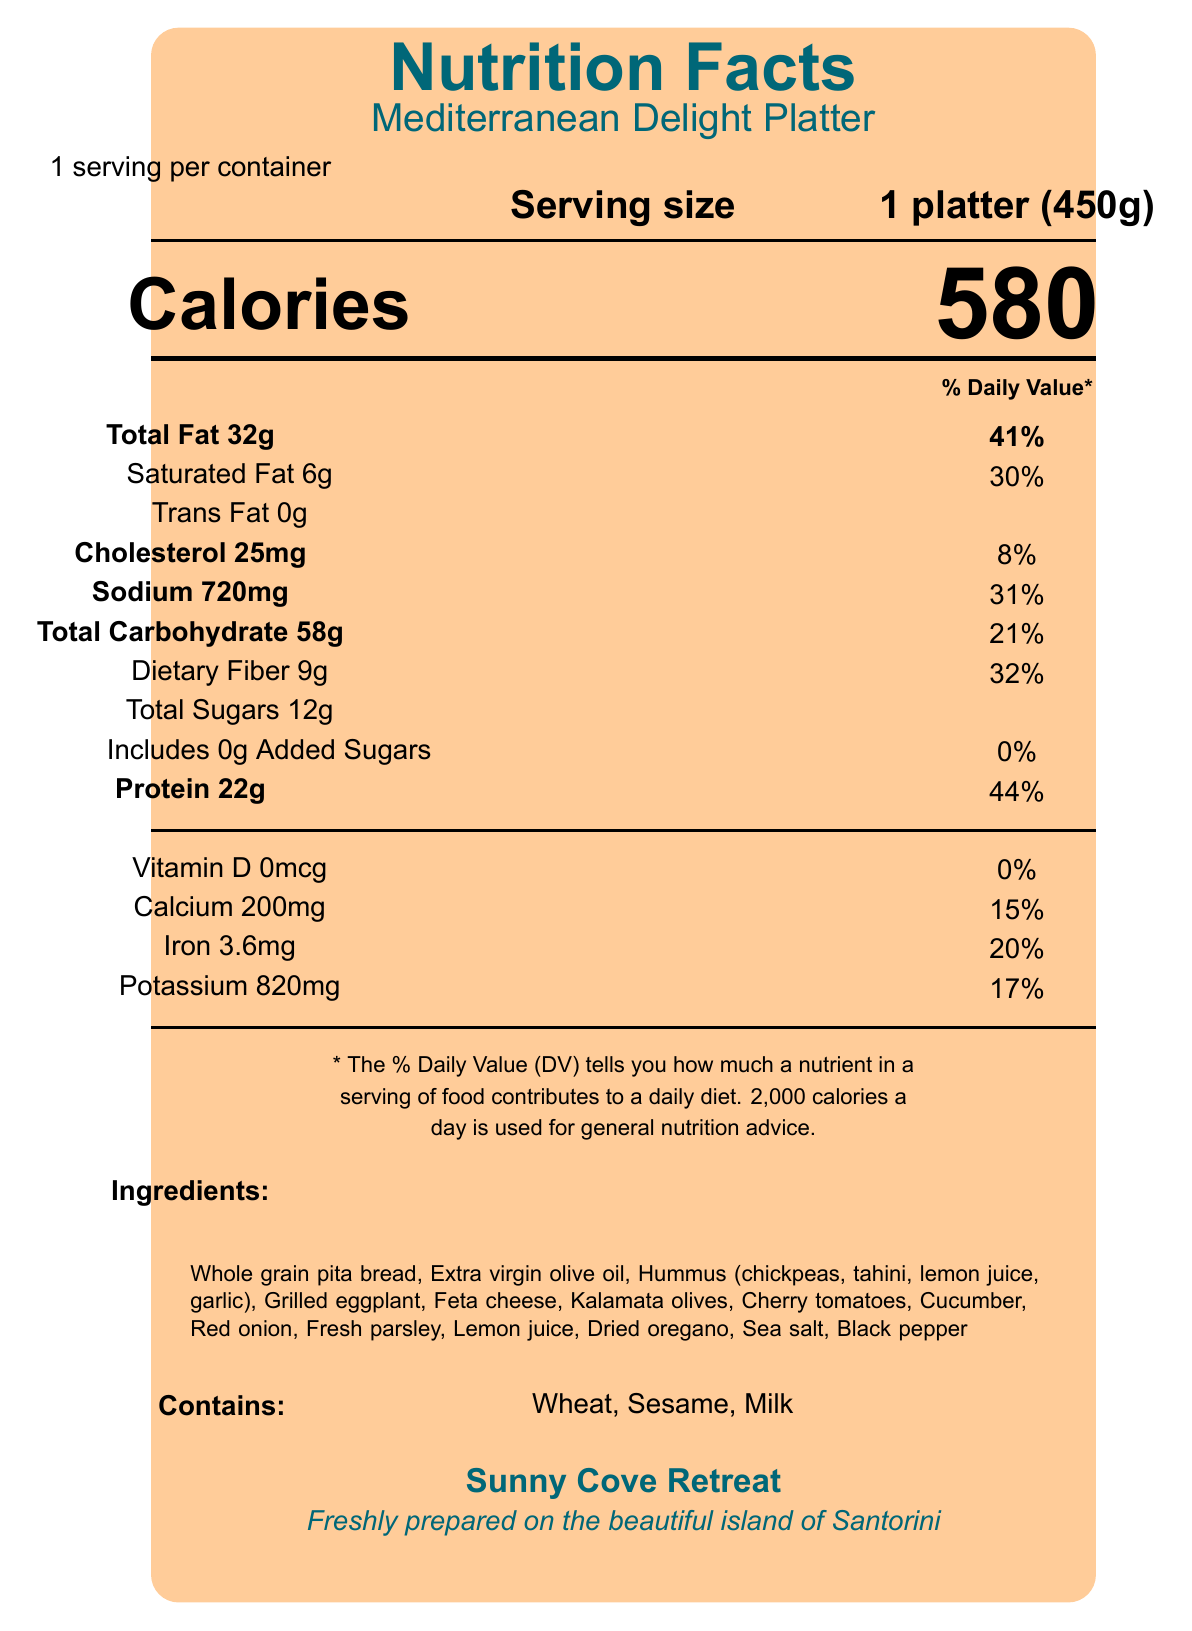what is the serving size of the Mediterranean Delight Platter? The serving size is clearly stated as "1 platter (450g)" in the document.
Answer: 1 platter (450g) how many calories are in one serving of the Mediterranean Delight Platter? The document specifies that there are 580 calories per serving.
Answer: 580 calories what is the percentage daily value of sodium in the serving? The document shows that the sodium content is 720mg and the daily value percentage is 31%.
Answer: 31% how much protein is in the Mediterranean Delight Platter? The document indicates that there is 22 grams of protein per serving.
Answer: 22g what allergens are present in the Mediterranean Delight Platter? The document mentions that the platter contains wheat, sesame, and milk.
Answer: Wheat, Sesame, Milk which of the following ingredients is NOT in the Mediterranean Delight Platter? 
A. Cucumber 
B. Red onion 
C. Mushrooms 
D. Feta cheese The ingredient list in the document does not include mushrooms.
Answer: C. Mushrooms what is the % daily value of dietary fiber? 
I. 32% 
II. 21% 
III. 17% 
IV. 44% The document states that the dietary fiber content is 9g, which is 32% of the daily value.
Answer: I. 32% is there any vitamin D in the Mediterranean Delight Platter? The document shows that the amount of Vitamin D is 0mcg, which is 0% of the daily value.
Answer: No briefly describe what the document is about The document provides a comprehensive look at the nutrition and content of the Mediterranean Delight Platter, including calories, macro and micronutrient amounts, ingredients, and allergen information.
Answer: The document is a Nutrition Facts Label for the Mediterranean Delight Platter served at Sunny Cove Retreat, located on the island of Santorini. It includes detailed nutritional information, ingredients, allergens, and additional information about the preparation and source of ingredients. where was the Mediterranean Delight Platter prepared? The document only mentions that the platter is "Freshly prepared on the beautiful island of Santorini," but it does not specify the exact location or facilities where it was prepared.
Answer: Not enough information 